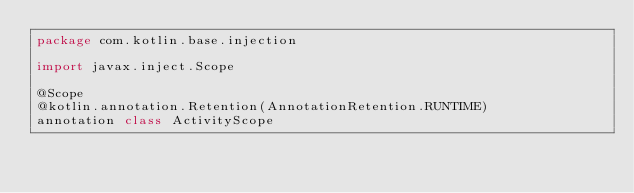<code> <loc_0><loc_0><loc_500><loc_500><_Kotlin_>package com.kotlin.base.injection

import javax.inject.Scope

@Scope
@kotlin.annotation.Retention(AnnotationRetention.RUNTIME)
annotation class ActivityScope</code> 